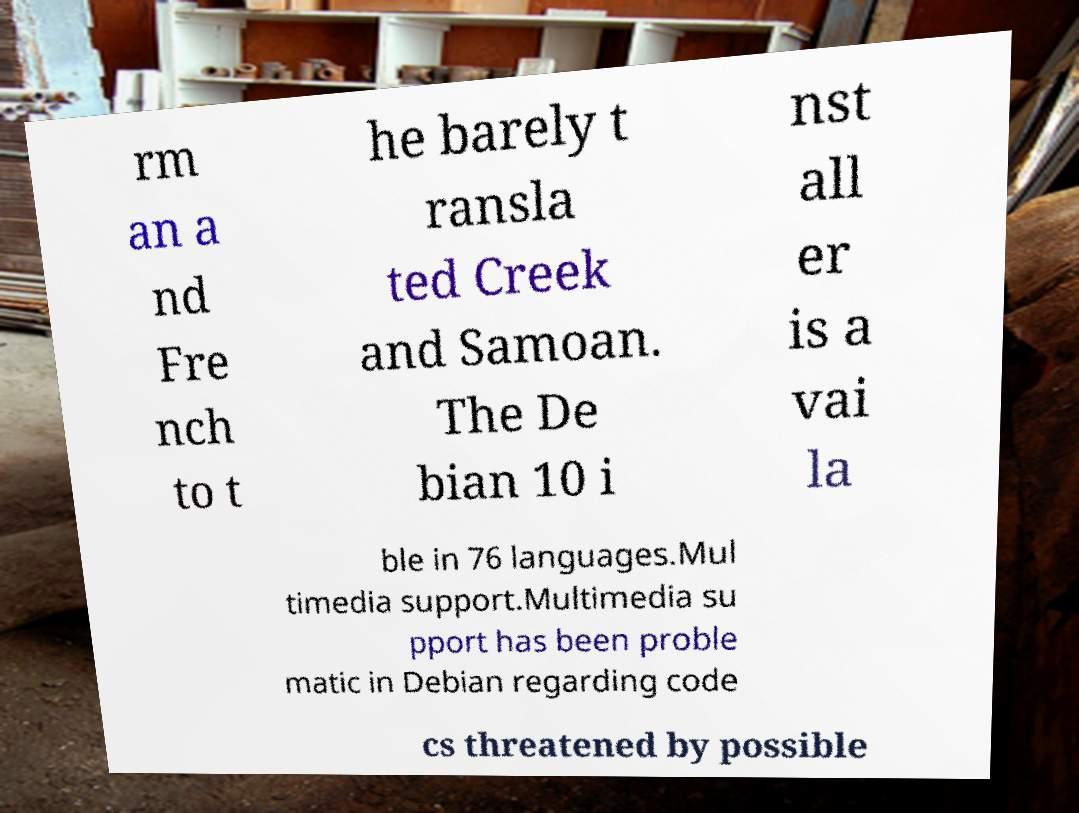Can you read and provide the text displayed in the image?This photo seems to have some interesting text. Can you extract and type it out for me? rm an a nd Fre nch to t he barely t ransla ted Creek and Samoan. The De bian 10 i nst all er is a vai la ble in 76 languages.Mul timedia support.Multimedia su pport has been proble matic in Debian regarding code cs threatened by possible 